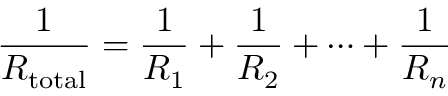Convert formula to latex. <formula><loc_0><loc_0><loc_500><loc_500>{ \frac { 1 } { R _ { t o t a l } } } = { \frac { 1 } { R _ { 1 } } } + { \frac { 1 } { R _ { 2 } } } + \cdots + { \frac { 1 } { R _ { n } } }</formula> 